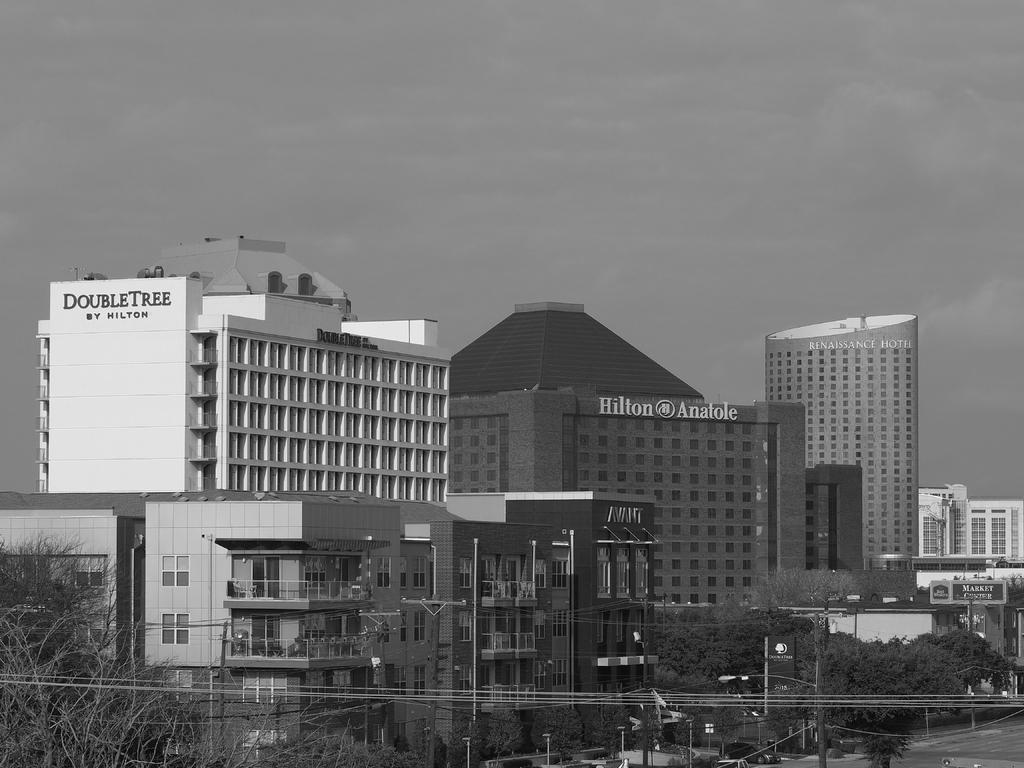Please provide a concise description of this image. This is the picture of a city. In this image there are buildings, trees, poles and wires. At the bottom there is a vehicle on the road. At the top there is sky and there are clouds and there is a text on the buildings. 